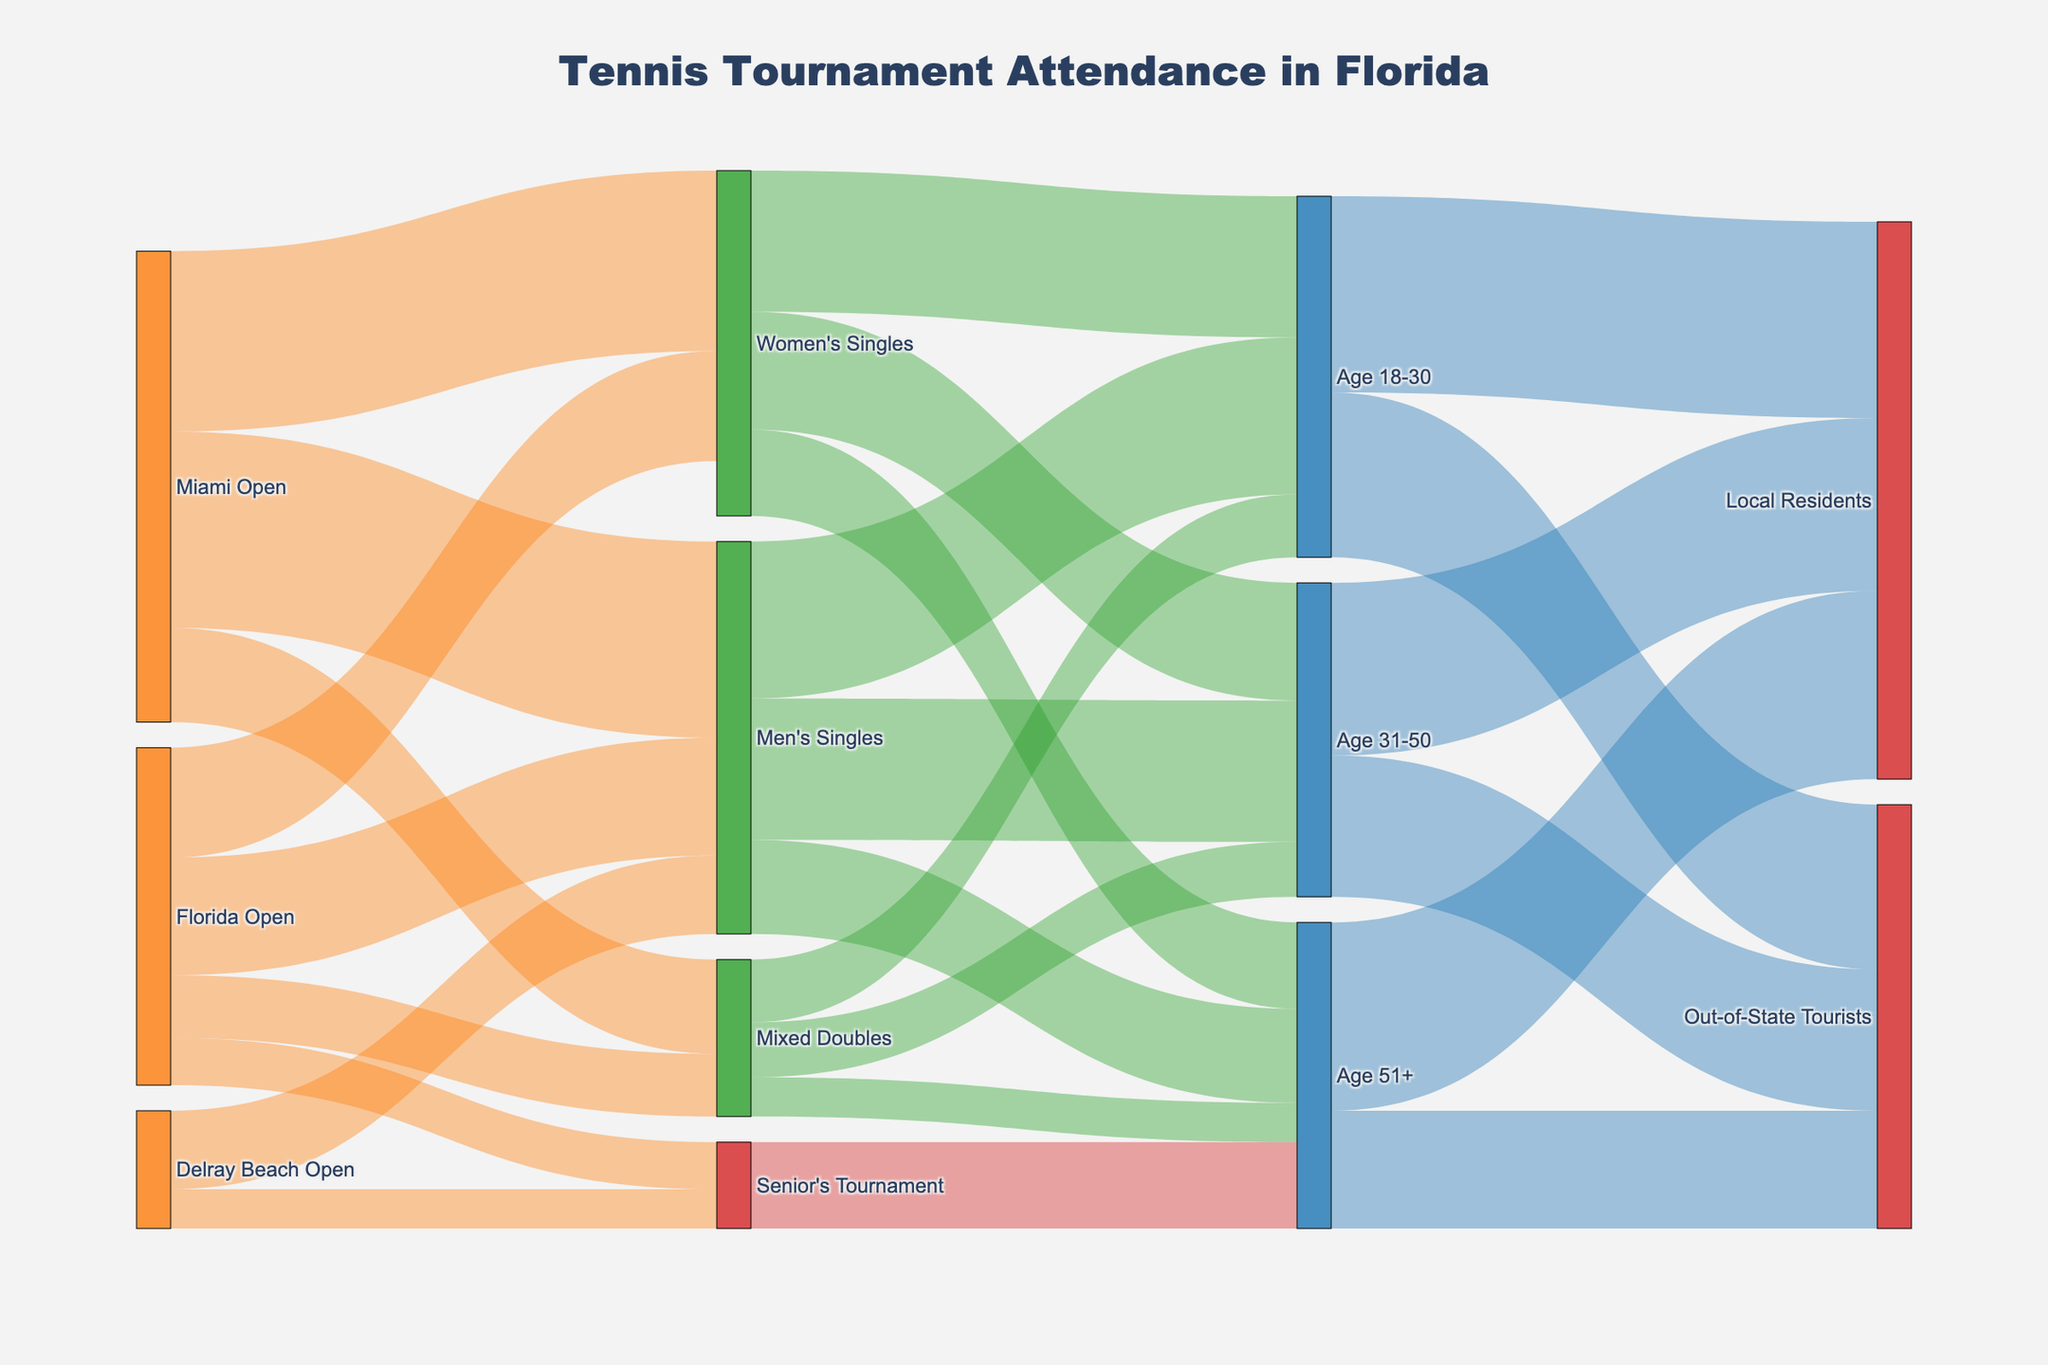How many events are shown in the Sankey diagram? The events are identified as sources in the Sankey plot. Count the unique sources: Florida Open, Miami Open, and Delray Beach Open.
Answer: 3 Which event type had the highest attendance in the Miami Open? For the Miami Open, compare the values for different event types: Men's Singles (25000), Women's Singles (23000), and Mixed Doubles (12000). The highest value is for Men's Singles.
Answer: Men's Singles What is the total attendance for the Senior's Tournament across all events? Sum the values for the Senior's Tournament across the Florida Open (6000) and Delray Beach Open (5000).
Answer: 11000 How many spectators in the Age 51+ group attended events? Look at the values connected to the Age 51+ group from different event types: Men's Singles (12000), Women's Singles (11000), Mixed Doubles (5000), Senior's Tournament (11000). Sum these values.
Answer: 39000 Compare the attendance for the Men's Singles and Women's Singles tournaments at the Florida Open. Which had more spectators and by how many? Compare the attendance: Men's Singles (15000) and Women's Singles (14000). The difference is 15000 - 14000.
Answer: 1000 Which demographic group among Age 18-30, Age 31-50, and Age 51+ had the highest local resident attendance? Compare the local resident attendance values for each age group: Age 18-30 (25000), Age 31-50 (22000), and Age 51+ (24000). Age 18-30 has the highest value.
Answer: Age 18-30 How many spectators aged 31-50 attended the Mixed Doubles events? Identify the value linked to the Mixed Doubles for the Age 31-50 group.
Answer: 7000 Was there more attendance by local residents or out-of-state tourists? Sum the values for local residents (25000+22000+24000) and out-of-state tourists (21000+18000+15000) respectively and compare.
Answer: Local residents What percentage of the Men's Singles spectators were aged 31-50? Sum the spectators for Men's Singles (20000+18000+12000) and calculate the percentage for the Age 31-50 group: (18000/50000) * 100%.
Answer: 36% Which tournament drew more spectators overall, the Florida Open or the Delray Beach Open? Sum the attendance in each tournament: Florida Open (15000+14000+8000+6000), Delray Beach Open (10000+5000) and compare.
Answer: Florida Open 